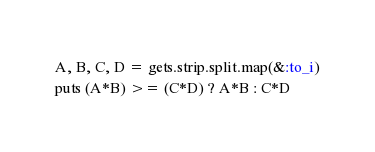<code> <loc_0><loc_0><loc_500><loc_500><_Ruby_>A, B, C, D = gets.strip.split.map(&:to_i)
puts (A*B) >= (C*D) ? A*B : C*D
</code> 